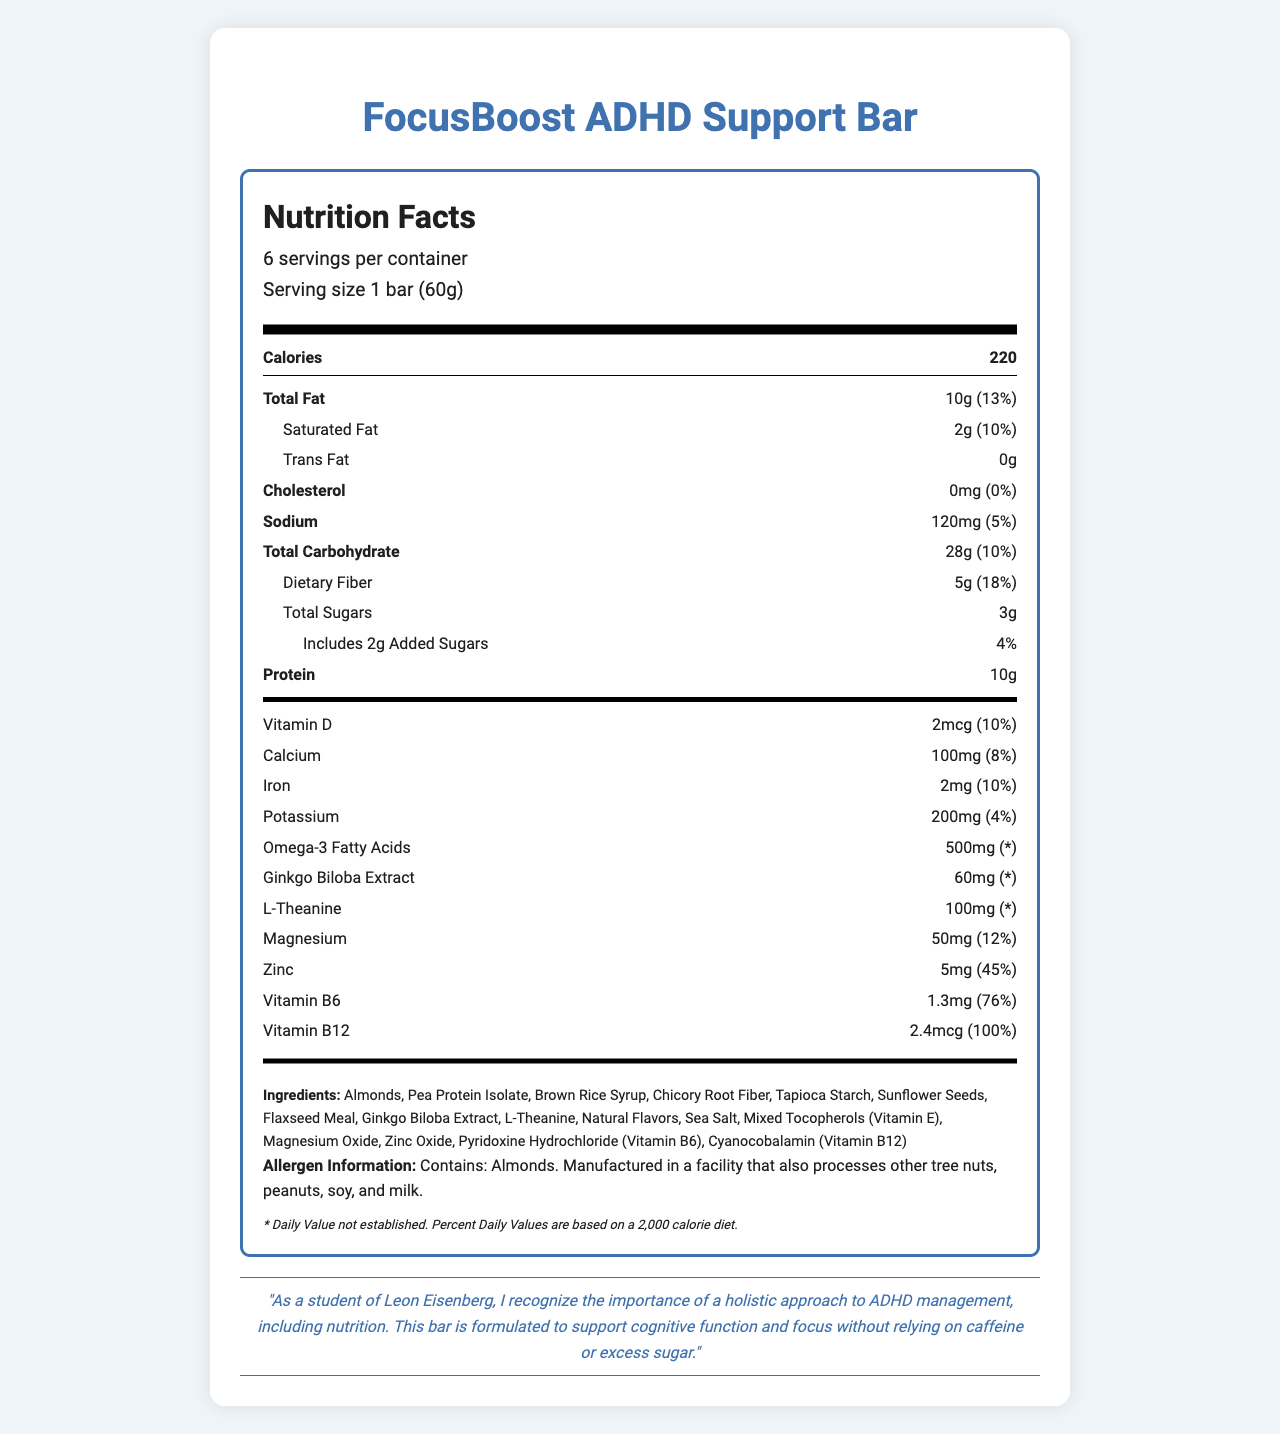What is the serving size of the FocusBoost ADHD Support Bar? The serving size is clearly listed as 1 bar weighing 60 grams.
Answer: 1 bar (60g) How many servings are in a container of the FocusBoost ADHD Support Bar? The label indicates that there are 6 servings per container.
Answer: 6 How much protein does one FocusBoost ADHD Support Bar contain? The bar contains 10 grams of protein per serving as specified on the nutrition label.
Answer: 10g What amount of dietary fiber is in one serving of the FocusBoost ADHD Support Bar? The nutritional information shows that there are 5 grams of dietary fiber per serving.
Answer: 5g What are the potential allergens listed in the FocusBoost ADHD Support Bar? The allergen information specifies that the bar contains almonds and is manufactured in a facility that processes other tree nuts, peanuts, soy, and milk.
Answer: Almonds. How many grams of total sugars are included in one FocusBoost ADHD Support Bar? According to the label, each bar contains 3 grams of total sugars.
Answer: 3g What is the daily value percentage of Vitamin B12 in the FocusBoost ADHD Support Bar? The nutritional information indicates that the bar provides 100% of the daily value for Vitamin B12.
Answer: 100% Which of the following vitamins/minerals does the FocusBoost ADHD Support Bar contain the highest percentage of daily value for? A. Calcium B. Zinc C. Vitamin B6 D. Vitamin B12 The FocusBoost bar contains 100% of the daily value for Vitamin B12, which is the highest compared to calcium (8%), zinc (45%), and vitamin B6 (76%).
Answer: D. Vitamin B12 Which of these ingredients is the essential fatty acid provided by the FocusBoost ADHD Support Bar? A. Omega-3 Fatty Acids B. L-Theanine C. Vitamin B6 D. Zinc Oxide Omega-3 Fatty Acids are listed as an ingredient and are the essential fatty acids included in the bar.
Answer: A. Omega-3 Fatty Acids Is the FocusBoost ADHD Support Bar caffeine-free? The document clearly states that the bar is formulated to support ADHD management without relying on caffeine.
Answer: Yes Summarize the main idea of the FocusBoost ADHD Support Bar's Nutrition Facts Label. The nutrition label provides detailed information about serving size, nutrients, vitamins, minerals, special ingredients for ADHD support, and allergen information to help consumers make informed decisions.
Answer: The FocusBoost ADHD Support Bar is a low-sugar, caffeine-free energy bar designed to support cognitive function and focus. It contains an array of nutrients including 10g of protein, 5g of dietary fiber, and supplement ingredients like omega-3 fatty acids, ginkgo biloba extract, and L-theanine. The bar also provides 100% of the daily value for Vitamin B12 and has minimal allergens, with almonds being the primary allergen. What are the daily value percentages for magnesium and potassium in one FocusBoost ADHD Support Bar? The nutrition label specifies that magnesium has a 12% daily value and potassium has a 4% daily value per serving.
Answer: Magnesium: 12%, Potassium: 4% Why is the there a disclaimer stating "* Daily Value not established."? The document does not provide an explanation or context for why some daily values are not established.
Answer: Cannot be determined How many milligrams of ginkgo biloba extract are in each serving of the FocusBoost ADHD Support Bar? The nutrition label specifies that there are 60 milligrams of ginkgo biloba extract per serving.
Answer: 60mg 